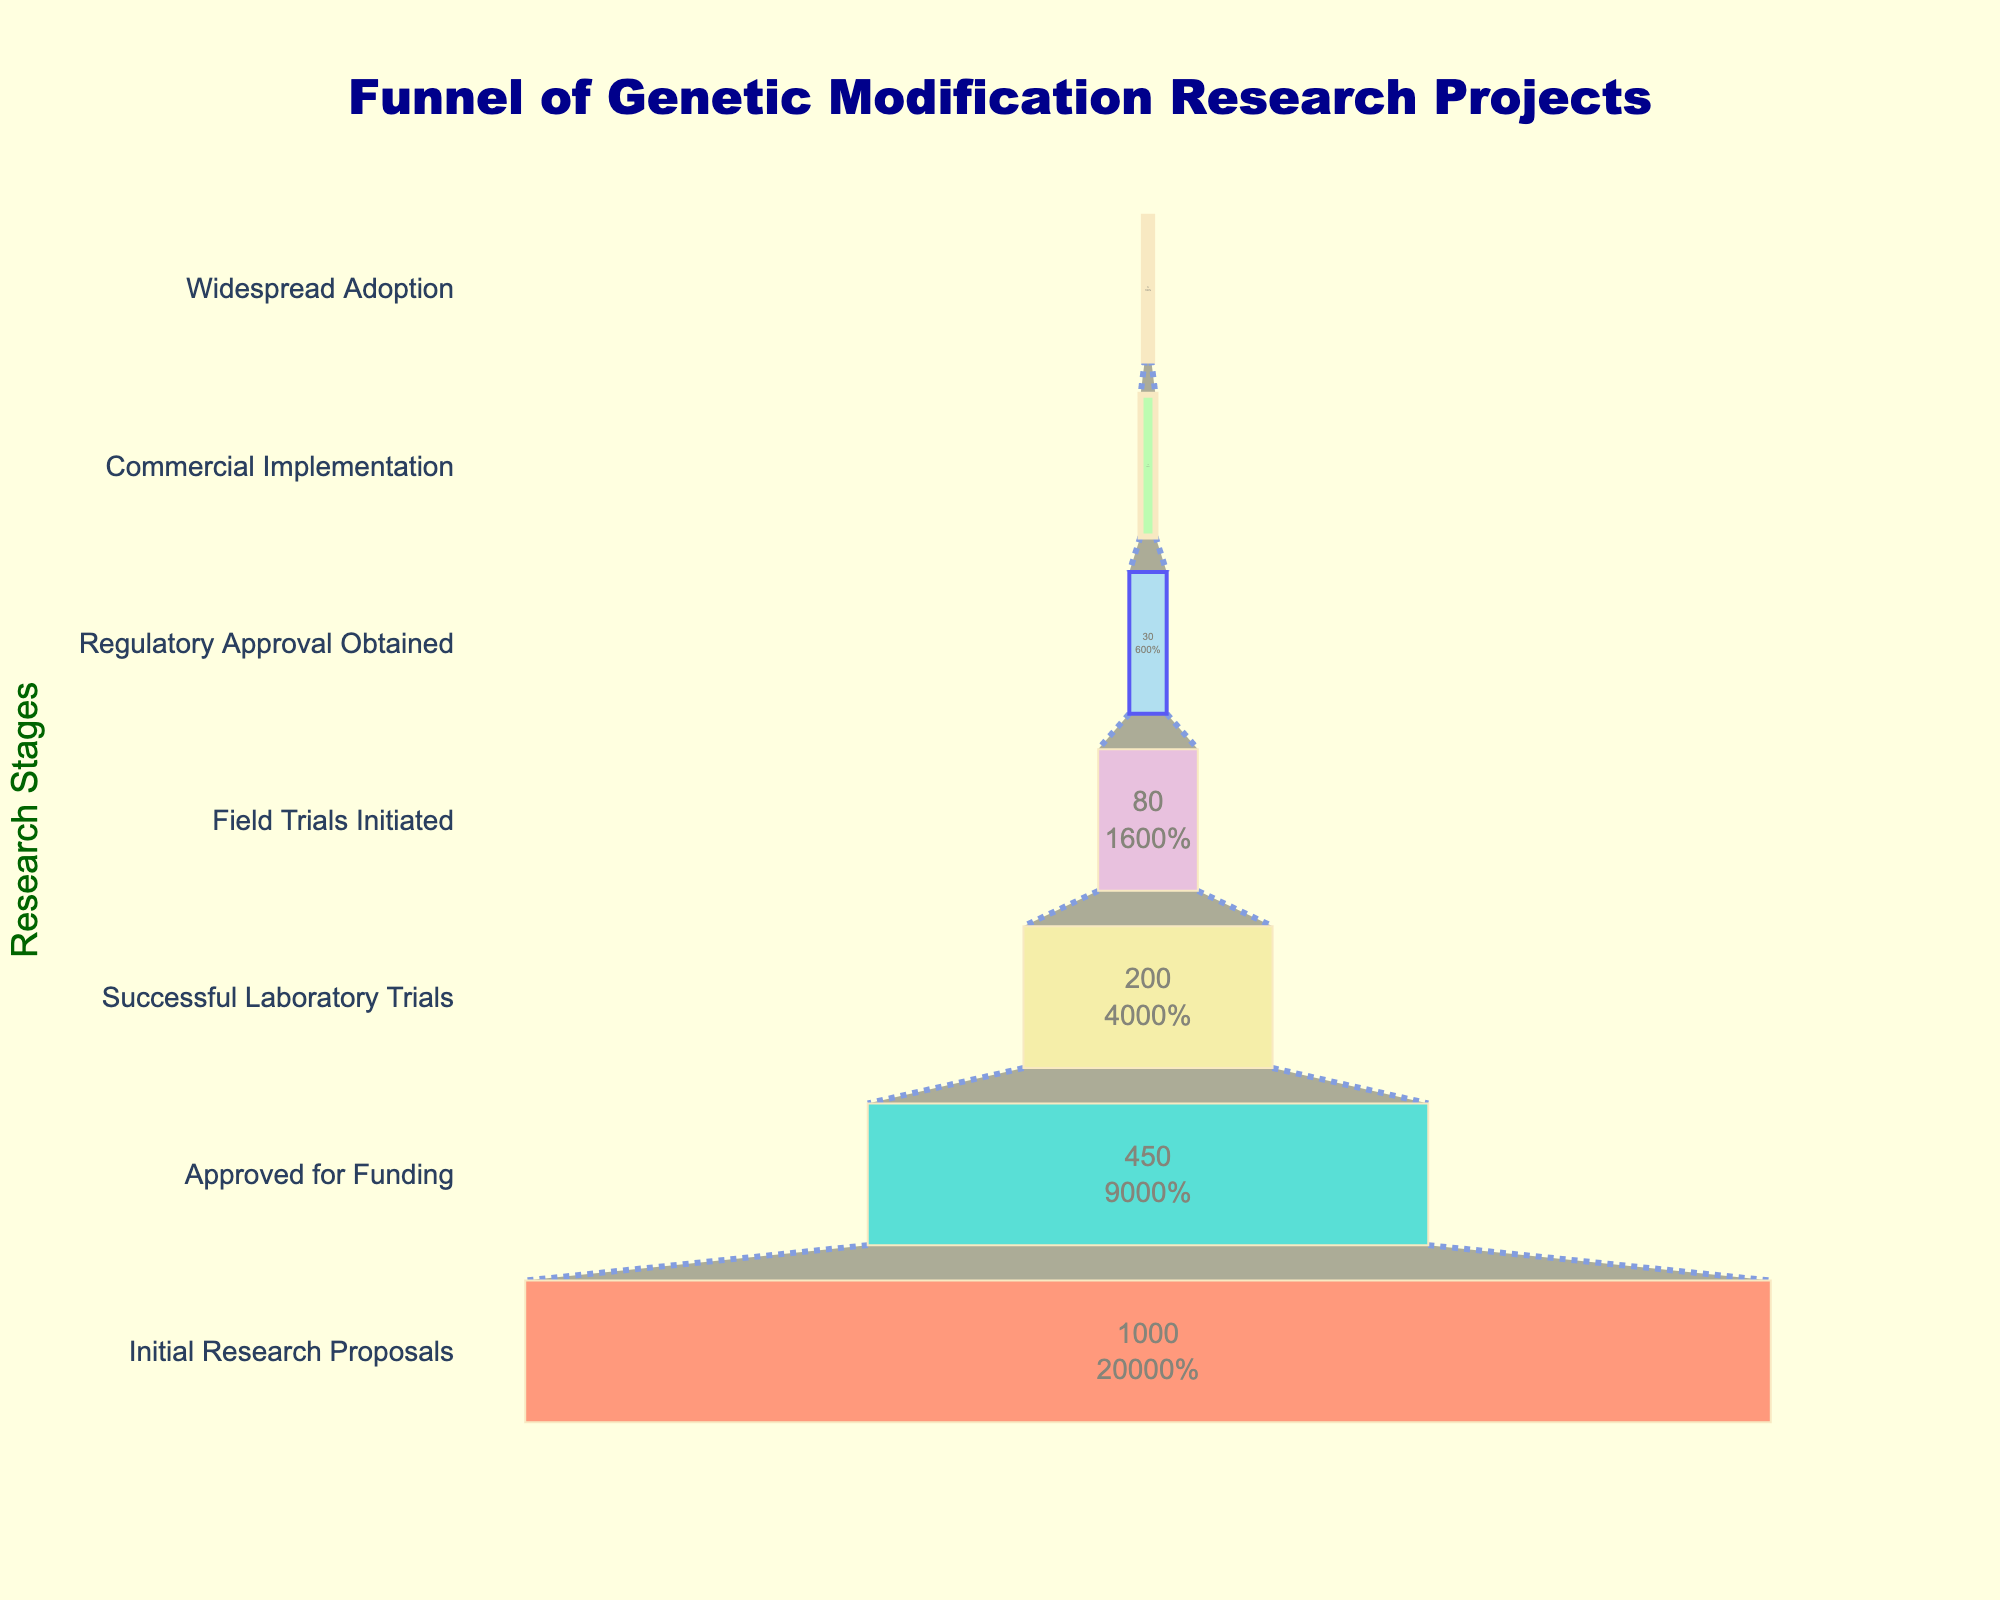what is the stage with the highest number of projects? The stage with the highest number of projects is at the top of the funnel. In this chart, the topmost stage is "Initial Research Proposals" with 1,000 projects.
Answer: Initial Research Proposals what is the number of projects that obtained regulatory approval? Look at the stage labeled "Regulatory Approval Obtained" in the chart, which shows the number of projects that have reached this stage. According to the chart, this number is 30.
Answer: 30 how many projects successfully transitioned from field trials to commercial implementation? The number of projects at the "Field Trials Initiated" stage is 80, and the number that reached "Commercial Implementation" is 12. Therefore, the number that successfully transitioned is 80 - 12 = 68.
Answer: 68 which stage has a higher percentage drop: from proposals to funding or from laboratory trials to field trials? Calculate the percentage drop for each transition. For proposals to funding: (1000 - 450) / 1000 * 100 = 55%. For laboratory trials to field trials: (200 - 80) / 200 * 100 = 60%. Therefore, the laboratory trials to field trials stage has a higher percentage drop.
Answer: Laboratory Trials to Field Trials what's the percentage of projects that went from initial proposals to widespread adoption? Look at the "Initial Research Proposals" and "Widespread Adoption" stages. The percentage is (5 / 1000) * 100 = 0.5%.
Answer: 0.5% how many stages are there in the funnel chart? Count the distinct stages from top to bottom in the funnel chart. There are seven stages in total.
Answer: 7 how does the color coding help in understanding the data? Each stage in the funnel chart has a unique color, which helps to easily distinguish between different stages and visualize the progression and attrition rate through the funnel.
Answer: Unique color coding what stage immediately follows the "Approved for Funding" stage? Look for the next stage after "Approved for Funding" in the funnel chart. The stage immediately following is "Successful Laboratory Trials".
Answer: Successful Laboratory Trials what is the average number of projects across all stages? Sum the number of projects across all stages (1000 + 450 + 200 + 80 + 30 + 12 + 5) = 1777. Divide by the number of stages: 1777 / 7 ≈ 254.
Answer: 254 what's the difference in the number of projects between the "Field Trials Initiated" stage and "Widespread Adoption"? Look at the values for both stages: "Field Trials Initiated" has 80 projects and "Widespread Adoption" has 5. The difference is 80 - 5 = 75.
Answer: 75 